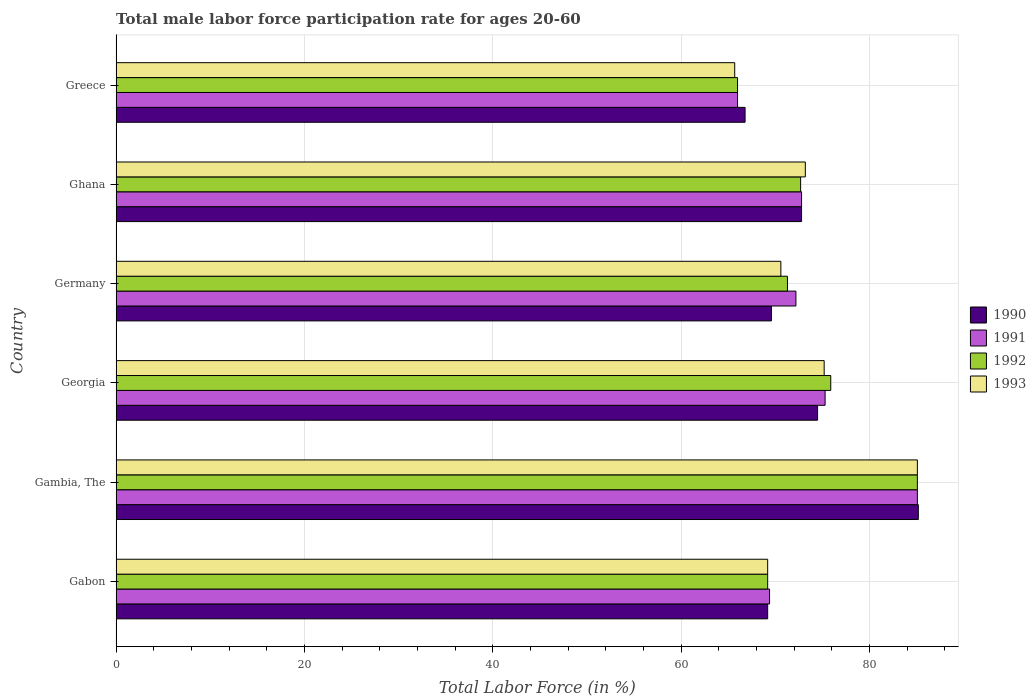How many groups of bars are there?
Ensure brevity in your answer.  6. Are the number of bars on each tick of the Y-axis equal?
Make the answer very short. Yes. How many bars are there on the 5th tick from the bottom?
Your answer should be very brief. 4. What is the label of the 2nd group of bars from the top?
Make the answer very short. Ghana. What is the male labor force participation rate in 1992 in Georgia?
Ensure brevity in your answer.  75.9. Across all countries, what is the maximum male labor force participation rate in 1992?
Keep it short and to the point. 85.1. Across all countries, what is the minimum male labor force participation rate in 1993?
Your response must be concise. 65.7. In which country was the male labor force participation rate in 1990 maximum?
Offer a terse response. Gambia, The. In which country was the male labor force participation rate in 1993 minimum?
Offer a terse response. Greece. What is the total male labor force participation rate in 1993 in the graph?
Keep it short and to the point. 439. What is the difference between the male labor force participation rate in 1990 in Gambia, The and that in Ghana?
Keep it short and to the point. 12.4. What is the difference between the male labor force participation rate in 1991 in Greece and the male labor force participation rate in 1992 in Germany?
Give a very brief answer. -5.3. What is the average male labor force participation rate in 1991 per country?
Provide a succinct answer. 73.47. What is the ratio of the male labor force participation rate in 1990 in Gambia, The to that in Germany?
Provide a short and direct response. 1.22. What is the difference between the highest and the second highest male labor force participation rate in 1993?
Provide a short and direct response. 9.9. What is the difference between the highest and the lowest male labor force participation rate in 1993?
Your response must be concise. 19.4. In how many countries, is the male labor force participation rate in 1990 greater than the average male labor force participation rate in 1990 taken over all countries?
Ensure brevity in your answer.  2. Is the sum of the male labor force participation rate in 1990 in Germany and Greece greater than the maximum male labor force participation rate in 1991 across all countries?
Provide a succinct answer. Yes. Is it the case that in every country, the sum of the male labor force participation rate in 1992 and male labor force participation rate in 1991 is greater than the sum of male labor force participation rate in 1990 and male labor force participation rate in 1993?
Keep it short and to the point. No. What does the 4th bar from the bottom in Ghana represents?
Provide a short and direct response. 1993. Is it the case that in every country, the sum of the male labor force participation rate in 1993 and male labor force participation rate in 1991 is greater than the male labor force participation rate in 1992?
Make the answer very short. Yes. How many bars are there?
Give a very brief answer. 24. Does the graph contain any zero values?
Give a very brief answer. No. What is the title of the graph?
Give a very brief answer. Total male labor force participation rate for ages 20-60. What is the label or title of the X-axis?
Make the answer very short. Total Labor Force (in %). What is the label or title of the Y-axis?
Your answer should be compact. Country. What is the Total Labor Force (in %) in 1990 in Gabon?
Provide a succinct answer. 69.2. What is the Total Labor Force (in %) of 1991 in Gabon?
Offer a terse response. 69.4. What is the Total Labor Force (in %) of 1992 in Gabon?
Keep it short and to the point. 69.2. What is the Total Labor Force (in %) of 1993 in Gabon?
Offer a terse response. 69.2. What is the Total Labor Force (in %) of 1990 in Gambia, The?
Make the answer very short. 85.2. What is the Total Labor Force (in %) in 1991 in Gambia, The?
Provide a succinct answer. 85.1. What is the Total Labor Force (in %) in 1992 in Gambia, The?
Your response must be concise. 85.1. What is the Total Labor Force (in %) of 1993 in Gambia, The?
Your response must be concise. 85.1. What is the Total Labor Force (in %) of 1990 in Georgia?
Provide a succinct answer. 74.5. What is the Total Labor Force (in %) of 1991 in Georgia?
Your response must be concise. 75.3. What is the Total Labor Force (in %) of 1992 in Georgia?
Keep it short and to the point. 75.9. What is the Total Labor Force (in %) in 1993 in Georgia?
Your answer should be very brief. 75.2. What is the Total Labor Force (in %) in 1990 in Germany?
Provide a short and direct response. 69.6. What is the Total Labor Force (in %) of 1991 in Germany?
Give a very brief answer. 72.2. What is the Total Labor Force (in %) of 1992 in Germany?
Keep it short and to the point. 71.3. What is the Total Labor Force (in %) of 1993 in Germany?
Make the answer very short. 70.6. What is the Total Labor Force (in %) in 1990 in Ghana?
Provide a succinct answer. 72.8. What is the Total Labor Force (in %) of 1991 in Ghana?
Your answer should be very brief. 72.8. What is the Total Labor Force (in %) in 1992 in Ghana?
Give a very brief answer. 72.7. What is the Total Labor Force (in %) in 1993 in Ghana?
Your answer should be compact. 73.2. What is the Total Labor Force (in %) of 1990 in Greece?
Offer a very short reply. 66.8. What is the Total Labor Force (in %) of 1993 in Greece?
Keep it short and to the point. 65.7. Across all countries, what is the maximum Total Labor Force (in %) of 1990?
Your answer should be very brief. 85.2. Across all countries, what is the maximum Total Labor Force (in %) of 1991?
Offer a terse response. 85.1. Across all countries, what is the maximum Total Labor Force (in %) in 1992?
Ensure brevity in your answer.  85.1. Across all countries, what is the maximum Total Labor Force (in %) of 1993?
Your response must be concise. 85.1. Across all countries, what is the minimum Total Labor Force (in %) in 1990?
Your answer should be compact. 66.8. Across all countries, what is the minimum Total Labor Force (in %) in 1992?
Provide a short and direct response. 66. Across all countries, what is the minimum Total Labor Force (in %) of 1993?
Provide a succinct answer. 65.7. What is the total Total Labor Force (in %) of 1990 in the graph?
Your answer should be very brief. 438.1. What is the total Total Labor Force (in %) in 1991 in the graph?
Offer a terse response. 440.8. What is the total Total Labor Force (in %) in 1992 in the graph?
Provide a short and direct response. 440.2. What is the total Total Labor Force (in %) of 1993 in the graph?
Give a very brief answer. 439. What is the difference between the Total Labor Force (in %) of 1990 in Gabon and that in Gambia, The?
Ensure brevity in your answer.  -16. What is the difference between the Total Labor Force (in %) of 1991 in Gabon and that in Gambia, The?
Ensure brevity in your answer.  -15.7. What is the difference between the Total Labor Force (in %) in 1992 in Gabon and that in Gambia, The?
Ensure brevity in your answer.  -15.9. What is the difference between the Total Labor Force (in %) in 1993 in Gabon and that in Gambia, The?
Make the answer very short. -15.9. What is the difference between the Total Labor Force (in %) in 1992 in Gabon and that in Georgia?
Ensure brevity in your answer.  -6.7. What is the difference between the Total Labor Force (in %) in 1993 in Gabon and that in Georgia?
Make the answer very short. -6. What is the difference between the Total Labor Force (in %) of 1990 in Gabon and that in Germany?
Provide a short and direct response. -0.4. What is the difference between the Total Labor Force (in %) in 1991 in Gabon and that in Germany?
Keep it short and to the point. -2.8. What is the difference between the Total Labor Force (in %) of 1993 in Gabon and that in Germany?
Keep it short and to the point. -1.4. What is the difference between the Total Labor Force (in %) in 1990 in Gabon and that in Ghana?
Ensure brevity in your answer.  -3.6. What is the difference between the Total Labor Force (in %) in 1991 in Gabon and that in Ghana?
Offer a very short reply. -3.4. What is the difference between the Total Labor Force (in %) in 1993 in Gabon and that in Ghana?
Provide a short and direct response. -4. What is the difference between the Total Labor Force (in %) in 1991 in Gabon and that in Greece?
Offer a very short reply. 3.4. What is the difference between the Total Labor Force (in %) in 1992 in Gabon and that in Greece?
Offer a very short reply. 3.2. What is the difference between the Total Labor Force (in %) of 1990 in Gambia, The and that in Georgia?
Your answer should be compact. 10.7. What is the difference between the Total Labor Force (in %) of 1992 in Gambia, The and that in Germany?
Give a very brief answer. 13.8. What is the difference between the Total Labor Force (in %) of 1993 in Gambia, The and that in Germany?
Give a very brief answer. 14.5. What is the difference between the Total Labor Force (in %) of 1991 in Gambia, The and that in Ghana?
Make the answer very short. 12.3. What is the difference between the Total Labor Force (in %) of 1993 in Gambia, The and that in Ghana?
Give a very brief answer. 11.9. What is the difference between the Total Labor Force (in %) of 1990 in Georgia and that in Germany?
Your answer should be compact. 4.9. What is the difference between the Total Labor Force (in %) of 1990 in Georgia and that in Ghana?
Your answer should be compact. 1.7. What is the difference between the Total Labor Force (in %) of 1991 in Georgia and that in Ghana?
Ensure brevity in your answer.  2.5. What is the difference between the Total Labor Force (in %) of 1992 in Georgia and that in Ghana?
Your answer should be very brief. 3.2. What is the difference between the Total Labor Force (in %) in 1992 in Georgia and that in Greece?
Make the answer very short. 9.9. What is the difference between the Total Labor Force (in %) of 1993 in Georgia and that in Greece?
Ensure brevity in your answer.  9.5. What is the difference between the Total Labor Force (in %) in 1990 in Germany and that in Ghana?
Your answer should be very brief. -3.2. What is the difference between the Total Labor Force (in %) in 1991 in Germany and that in Ghana?
Provide a succinct answer. -0.6. What is the difference between the Total Labor Force (in %) of 1992 in Germany and that in Ghana?
Provide a succinct answer. -1.4. What is the difference between the Total Labor Force (in %) of 1990 in Germany and that in Greece?
Provide a short and direct response. 2.8. What is the difference between the Total Labor Force (in %) of 1991 in Germany and that in Greece?
Keep it short and to the point. 6.2. What is the difference between the Total Labor Force (in %) of 1992 in Germany and that in Greece?
Offer a very short reply. 5.3. What is the difference between the Total Labor Force (in %) in 1993 in Germany and that in Greece?
Offer a terse response. 4.9. What is the difference between the Total Labor Force (in %) of 1992 in Ghana and that in Greece?
Make the answer very short. 6.7. What is the difference between the Total Labor Force (in %) in 1990 in Gabon and the Total Labor Force (in %) in 1991 in Gambia, The?
Ensure brevity in your answer.  -15.9. What is the difference between the Total Labor Force (in %) of 1990 in Gabon and the Total Labor Force (in %) of 1992 in Gambia, The?
Ensure brevity in your answer.  -15.9. What is the difference between the Total Labor Force (in %) in 1990 in Gabon and the Total Labor Force (in %) in 1993 in Gambia, The?
Your answer should be very brief. -15.9. What is the difference between the Total Labor Force (in %) of 1991 in Gabon and the Total Labor Force (in %) of 1992 in Gambia, The?
Offer a very short reply. -15.7. What is the difference between the Total Labor Force (in %) of 1991 in Gabon and the Total Labor Force (in %) of 1993 in Gambia, The?
Provide a short and direct response. -15.7. What is the difference between the Total Labor Force (in %) in 1992 in Gabon and the Total Labor Force (in %) in 1993 in Gambia, The?
Provide a succinct answer. -15.9. What is the difference between the Total Labor Force (in %) of 1990 in Gabon and the Total Labor Force (in %) of 1993 in Georgia?
Your answer should be compact. -6. What is the difference between the Total Labor Force (in %) of 1991 in Gabon and the Total Labor Force (in %) of 1992 in Georgia?
Provide a short and direct response. -6.5. What is the difference between the Total Labor Force (in %) of 1992 in Gabon and the Total Labor Force (in %) of 1993 in Georgia?
Your answer should be very brief. -6. What is the difference between the Total Labor Force (in %) in 1992 in Gabon and the Total Labor Force (in %) in 1993 in Germany?
Your answer should be very brief. -1.4. What is the difference between the Total Labor Force (in %) of 1990 in Gabon and the Total Labor Force (in %) of 1992 in Greece?
Make the answer very short. 3.2. What is the difference between the Total Labor Force (in %) in 1992 in Gabon and the Total Labor Force (in %) in 1993 in Greece?
Provide a succinct answer. 3.5. What is the difference between the Total Labor Force (in %) of 1990 in Gambia, The and the Total Labor Force (in %) of 1993 in Georgia?
Offer a terse response. 10. What is the difference between the Total Labor Force (in %) in 1992 in Gambia, The and the Total Labor Force (in %) in 1993 in Georgia?
Ensure brevity in your answer.  9.9. What is the difference between the Total Labor Force (in %) of 1990 in Gambia, The and the Total Labor Force (in %) of 1992 in Germany?
Make the answer very short. 13.9. What is the difference between the Total Labor Force (in %) in 1990 in Gambia, The and the Total Labor Force (in %) in 1993 in Germany?
Provide a succinct answer. 14.6. What is the difference between the Total Labor Force (in %) in 1991 in Gambia, The and the Total Labor Force (in %) in 1992 in Germany?
Provide a short and direct response. 13.8. What is the difference between the Total Labor Force (in %) of 1992 in Gambia, The and the Total Labor Force (in %) of 1993 in Germany?
Offer a very short reply. 14.5. What is the difference between the Total Labor Force (in %) in 1990 in Gambia, The and the Total Labor Force (in %) in 1992 in Ghana?
Offer a very short reply. 12.5. What is the difference between the Total Labor Force (in %) of 1990 in Gambia, The and the Total Labor Force (in %) of 1993 in Ghana?
Keep it short and to the point. 12. What is the difference between the Total Labor Force (in %) in 1991 in Gambia, The and the Total Labor Force (in %) in 1993 in Ghana?
Provide a succinct answer. 11.9. What is the difference between the Total Labor Force (in %) of 1990 in Gambia, The and the Total Labor Force (in %) of 1991 in Greece?
Ensure brevity in your answer.  19.2. What is the difference between the Total Labor Force (in %) in 1990 in Gambia, The and the Total Labor Force (in %) in 1992 in Greece?
Your response must be concise. 19.2. What is the difference between the Total Labor Force (in %) of 1990 in Gambia, The and the Total Labor Force (in %) of 1993 in Greece?
Make the answer very short. 19.5. What is the difference between the Total Labor Force (in %) of 1991 in Gambia, The and the Total Labor Force (in %) of 1992 in Greece?
Your answer should be compact. 19.1. What is the difference between the Total Labor Force (in %) of 1992 in Gambia, The and the Total Labor Force (in %) of 1993 in Greece?
Provide a short and direct response. 19.4. What is the difference between the Total Labor Force (in %) of 1990 in Georgia and the Total Labor Force (in %) of 1992 in Germany?
Offer a terse response. 3.2. What is the difference between the Total Labor Force (in %) of 1990 in Georgia and the Total Labor Force (in %) of 1991 in Ghana?
Your answer should be compact. 1.7. What is the difference between the Total Labor Force (in %) in 1990 in Georgia and the Total Labor Force (in %) in 1993 in Ghana?
Your answer should be compact. 1.3. What is the difference between the Total Labor Force (in %) of 1991 in Georgia and the Total Labor Force (in %) of 1992 in Ghana?
Provide a succinct answer. 2.6. What is the difference between the Total Labor Force (in %) in 1991 in Georgia and the Total Labor Force (in %) in 1993 in Ghana?
Make the answer very short. 2.1. What is the difference between the Total Labor Force (in %) in 1990 in Georgia and the Total Labor Force (in %) in 1991 in Greece?
Your answer should be compact. 8.5. What is the difference between the Total Labor Force (in %) in 1990 in Georgia and the Total Labor Force (in %) in 1992 in Greece?
Your response must be concise. 8.5. What is the difference between the Total Labor Force (in %) of 1990 in Georgia and the Total Labor Force (in %) of 1993 in Greece?
Give a very brief answer. 8.8. What is the difference between the Total Labor Force (in %) in 1991 in Georgia and the Total Labor Force (in %) in 1993 in Greece?
Your answer should be very brief. 9.6. What is the difference between the Total Labor Force (in %) of 1992 in Georgia and the Total Labor Force (in %) of 1993 in Greece?
Your answer should be compact. 10.2. What is the difference between the Total Labor Force (in %) in 1990 in Germany and the Total Labor Force (in %) in 1992 in Ghana?
Ensure brevity in your answer.  -3.1. What is the difference between the Total Labor Force (in %) in 1991 in Germany and the Total Labor Force (in %) in 1993 in Ghana?
Ensure brevity in your answer.  -1. What is the difference between the Total Labor Force (in %) of 1990 in Germany and the Total Labor Force (in %) of 1991 in Greece?
Make the answer very short. 3.6. What is the difference between the Total Labor Force (in %) in 1990 in Germany and the Total Labor Force (in %) in 1992 in Greece?
Provide a succinct answer. 3.6. What is the difference between the Total Labor Force (in %) in 1990 in Germany and the Total Labor Force (in %) in 1993 in Greece?
Keep it short and to the point. 3.9. What is the difference between the Total Labor Force (in %) of 1991 in Ghana and the Total Labor Force (in %) of 1992 in Greece?
Your answer should be compact. 6.8. What is the difference between the Total Labor Force (in %) of 1992 in Ghana and the Total Labor Force (in %) of 1993 in Greece?
Provide a short and direct response. 7. What is the average Total Labor Force (in %) in 1990 per country?
Keep it short and to the point. 73.02. What is the average Total Labor Force (in %) of 1991 per country?
Give a very brief answer. 73.47. What is the average Total Labor Force (in %) of 1992 per country?
Your response must be concise. 73.37. What is the average Total Labor Force (in %) in 1993 per country?
Give a very brief answer. 73.17. What is the difference between the Total Labor Force (in %) in 1991 and Total Labor Force (in %) in 1993 in Gabon?
Provide a succinct answer. 0.2. What is the difference between the Total Labor Force (in %) of 1992 and Total Labor Force (in %) of 1993 in Gabon?
Make the answer very short. 0. What is the difference between the Total Labor Force (in %) of 1990 and Total Labor Force (in %) of 1991 in Gambia, The?
Ensure brevity in your answer.  0.1. What is the difference between the Total Labor Force (in %) of 1990 and Total Labor Force (in %) of 1993 in Gambia, The?
Provide a succinct answer. 0.1. What is the difference between the Total Labor Force (in %) of 1991 and Total Labor Force (in %) of 1992 in Gambia, The?
Offer a very short reply. 0. What is the difference between the Total Labor Force (in %) in 1991 and Total Labor Force (in %) in 1992 in Georgia?
Provide a short and direct response. -0.6. What is the difference between the Total Labor Force (in %) of 1991 and Total Labor Force (in %) of 1993 in Georgia?
Give a very brief answer. 0.1. What is the difference between the Total Labor Force (in %) of 1992 and Total Labor Force (in %) of 1993 in Georgia?
Provide a short and direct response. 0.7. What is the difference between the Total Labor Force (in %) of 1990 and Total Labor Force (in %) of 1991 in Germany?
Your response must be concise. -2.6. What is the difference between the Total Labor Force (in %) of 1990 and Total Labor Force (in %) of 1992 in Germany?
Make the answer very short. -1.7. What is the difference between the Total Labor Force (in %) in 1991 and Total Labor Force (in %) in 1992 in Germany?
Your answer should be compact. 0.9. What is the difference between the Total Labor Force (in %) of 1992 and Total Labor Force (in %) of 1993 in Germany?
Your answer should be very brief. 0.7. What is the difference between the Total Labor Force (in %) in 1992 and Total Labor Force (in %) in 1993 in Ghana?
Offer a very short reply. -0.5. What is the difference between the Total Labor Force (in %) in 1990 and Total Labor Force (in %) in 1991 in Greece?
Offer a very short reply. 0.8. What is the difference between the Total Labor Force (in %) of 1990 and Total Labor Force (in %) of 1992 in Greece?
Make the answer very short. 0.8. What is the difference between the Total Labor Force (in %) of 1990 and Total Labor Force (in %) of 1993 in Greece?
Keep it short and to the point. 1.1. What is the difference between the Total Labor Force (in %) of 1991 and Total Labor Force (in %) of 1993 in Greece?
Make the answer very short. 0.3. What is the ratio of the Total Labor Force (in %) of 1990 in Gabon to that in Gambia, The?
Give a very brief answer. 0.81. What is the ratio of the Total Labor Force (in %) in 1991 in Gabon to that in Gambia, The?
Make the answer very short. 0.82. What is the ratio of the Total Labor Force (in %) in 1992 in Gabon to that in Gambia, The?
Give a very brief answer. 0.81. What is the ratio of the Total Labor Force (in %) in 1993 in Gabon to that in Gambia, The?
Provide a short and direct response. 0.81. What is the ratio of the Total Labor Force (in %) in 1990 in Gabon to that in Georgia?
Ensure brevity in your answer.  0.93. What is the ratio of the Total Labor Force (in %) in 1991 in Gabon to that in Georgia?
Your answer should be very brief. 0.92. What is the ratio of the Total Labor Force (in %) in 1992 in Gabon to that in Georgia?
Your answer should be compact. 0.91. What is the ratio of the Total Labor Force (in %) in 1993 in Gabon to that in Georgia?
Offer a terse response. 0.92. What is the ratio of the Total Labor Force (in %) in 1990 in Gabon to that in Germany?
Ensure brevity in your answer.  0.99. What is the ratio of the Total Labor Force (in %) in 1991 in Gabon to that in Germany?
Your answer should be very brief. 0.96. What is the ratio of the Total Labor Force (in %) of 1992 in Gabon to that in Germany?
Offer a very short reply. 0.97. What is the ratio of the Total Labor Force (in %) in 1993 in Gabon to that in Germany?
Ensure brevity in your answer.  0.98. What is the ratio of the Total Labor Force (in %) of 1990 in Gabon to that in Ghana?
Provide a short and direct response. 0.95. What is the ratio of the Total Labor Force (in %) in 1991 in Gabon to that in Ghana?
Your response must be concise. 0.95. What is the ratio of the Total Labor Force (in %) in 1992 in Gabon to that in Ghana?
Offer a terse response. 0.95. What is the ratio of the Total Labor Force (in %) of 1993 in Gabon to that in Ghana?
Ensure brevity in your answer.  0.95. What is the ratio of the Total Labor Force (in %) of 1990 in Gabon to that in Greece?
Keep it short and to the point. 1.04. What is the ratio of the Total Labor Force (in %) in 1991 in Gabon to that in Greece?
Make the answer very short. 1.05. What is the ratio of the Total Labor Force (in %) of 1992 in Gabon to that in Greece?
Ensure brevity in your answer.  1.05. What is the ratio of the Total Labor Force (in %) in 1993 in Gabon to that in Greece?
Provide a succinct answer. 1.05. What is the ratio of the Total Labor Force (in %) in 1990 in Gambia, The to that in Georgia?
Offer a terse response. 1.14. What is the ratio of the Total Labor Force (in %) of 1991 in Gambia, The to that in Georgia?
Offer a very short reply. 1.13. What is the ratio of the Total Labor Force (in %) of 1992 in Gambia, The to that in Georgia?
Offer a very short reply. 1.12. What is the ratio of the Total Labor Force (in %) of 1993 in Gambia, The to that in Georgia?
Give a very brief answer. 1.13. What is the ratio of the Total Labor Force (in %) in 1990 in Gambia, The to that in Germany?
Provide a succinct answer. 1.22. What is the ratio of the Total Labor Force (in %) of 1991 in Gambia, The to that in Germany?
Provide a short and direct response. 1.18. What is the ratio of the Total Labor Force (in %) in 1992 in Gambia, The to that in Germany?
Your response must be concise. 1.19. What is the ratio of the Total Labor Force (in %) of 1993 in Gambia, The to that in Germany?
Give a very brief answer. 1.21. What is the ratio of the Total Labor Force (in %) of 1990 in Gambia, The to that in Ghana?
Provide a succinct answer. 1.17. What is the ratio of the Total Labor Force (in %) of 1991 in Gambia, The to that in Ghana?
Keep it short and to the point. 1.17. What is the ratio of the Total Labor Force (in %) in 1992 in Gambia, The to that in Ghana?
Give a very brief answer. 1.17. What is the ratio of the Total Labor Force (in %) in 1993 in Gambia, The to that in Ghana?
Offer a terse response. 1.16. What is the ratio of the Total Labor Force (in %) in 1990 in Gambia, The to that in Greece?
Make the answer very short. 1.28. What is the ratio of the Total Labor Force (in %) in 1991 in Gambia, The to that in Greece?
Provide a succinct answer. 1.29. What is the ratio of the Total Labor Force (in %) in 1992 in Gambia, The to that in Greece?
Make the answer very short. 1.29. What is the ratio of the Total Labor Force (in %) of 1993 in Gambia, The to that in Greece?
Give a very brief answer. 1.3. What is the ratio of the Total Labor Force (in %) of 1990 in Georgia to that in Germany?
Your response must be concise. 1.07. What is the ratio of the Total Labor Force (in %) of 1991 in Georgia to that in Germany?
Provide a succinct answer. 1.04. What is the ratio of the Total Labor Force (in %) in 1992 in Georgia to that in Germany?
Your answer should be very brief. 1.06. What is the ratio of the Total Labor Force (in %) in 1993 in Georgia to that in Germany?
Your answer should be compact. 1.07. What is the ratio of the Total Labor Force (in %) of 1990 in Georgia to that in Ghana?
Your response must be concise. 1.02. What is the ratio of the Total Labor Force (in %) of 1991 in Georgia to that in Ghana?
Make the answer very short. 1.03. What is the ratio of the Total Labor Force (in %) of 1992 in Georgia to that in Ghana?
Ensure brevity in your answer.  1.04. What is the ratio of the Total Labor Force (in %) in 1993 in Georgia to that in Ghana?
Keep it short and to the point. 1.03. What is the ratio of the Total Labor Force (in %) in 1990 in Georgia to that in Greece?
Keep it short and to the point. 1.12. What is the ratio of the Total Labor Force (in %) of 1991 in Georgia to that in Greece?
Offer a terse response. 1.14. What is the ratio of the Total Labor Force (in %) of 1992 in Georgia to that in Greece?
Provide a succinct answer. 1.15. What is the ratio of the Total Labor Force (in %) of 1993 in Georgia to that in Greece?
Provide a short and direct response. 1.14. What is the ratio of the Total Labor Force (in %) in 1990 in Germany to that in Ghana?
Your answer should be very brief. 0.96. What is the ratio of the Total Labor Force (in %) in 1991 in Germany to that in Ghana?
Offer a terse response. 0.99. What is the ratio of the Total Labor Force (in %) in 1992 in Germany to that in Ghana?
Ensure brevity in your answer.  0.98. What is the ratio of the Total Labor Force (in %) in 1993 in Germany to that in Ghana?
Provide a succinct answer. 0.96. What is the ratio of the Total Labor Force (in %) of 1990 in Germany to that in Greece?
Provide a short and direct response. 1.04. What is the ratio of the Total Labor Force (in %) in 1991 in Germany to that in Greece?
Your answer should be very brief. 1.09. What is the ratio of the Total Labor Force (in %) of 1992 in Germany to that in Greece?
Make the answer very short. 1.08. What is the ratio of the Total Labor Force (in %) in 1993 in Germany to that in Greece?
Your answer should be compact. 1.07. What is the ratio of the Total Labor Force (in %) in 1990 in Ghana to that in Greece?
Provide a succinct answer. 1.09. What is the ratio of the Total Labor Force (in %) in 1991 in Ghana to that in Greece?
Give a very brief answer. 1.1. What is the ratio of the Total Labor Force (in %) of 1992 in Ghana to that in Greece?
Your answer should be compact. 1.1. What is the ratio of the Total Labor Force (in %) of 1993 in Ghana to that in Greece?
Your response must be concise. 1.11. What is the difference between the highest and the second highest Total Labor Force (in %) in 1990?
Provide a succinct answer. 10.7. What is the difference between the highest and the second highest Total Labor Force (in %) in 1992?
Offer a terse response. 9.2. 